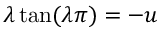Convert formula to latex. <formula><loc_0><loc_0><loc_500><loc_500>\lambda \tan ( \lambda \pi ) = - u</formula> 